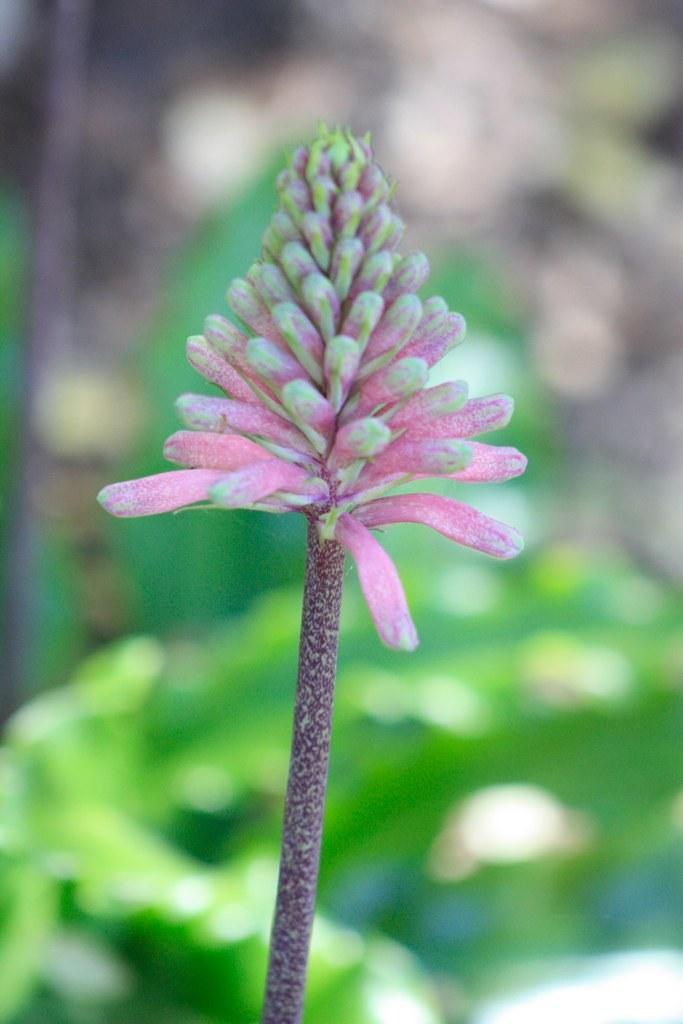What type of plant can be seen in the image? There is a flower with a stem in the image. What can be seen in the background of the image? There are trees in the background of the image. What type of bells can be heard ringing in the image? There are no bells present in the image, and therefore no sound can be heard. 